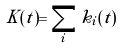<formula> <loc_0><loc_0><loc_500><loc_500>K ( t ) = \sum _ { i } k _ { i } ( t )</formula> 